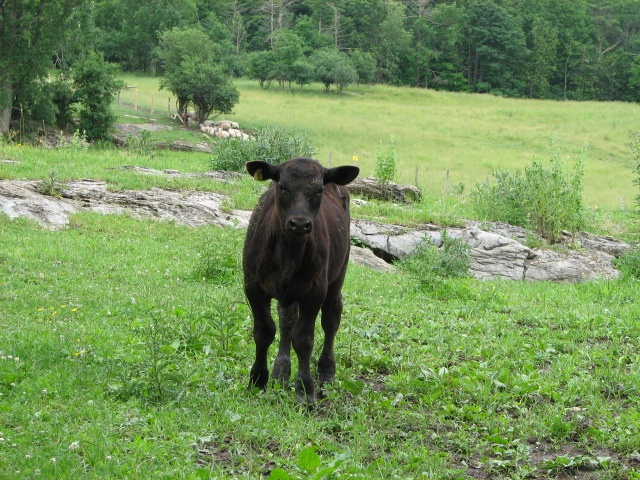Describe the objects in this image and their specific colors. I can see a cow in darkgreen, black, and gray tones in this image. 